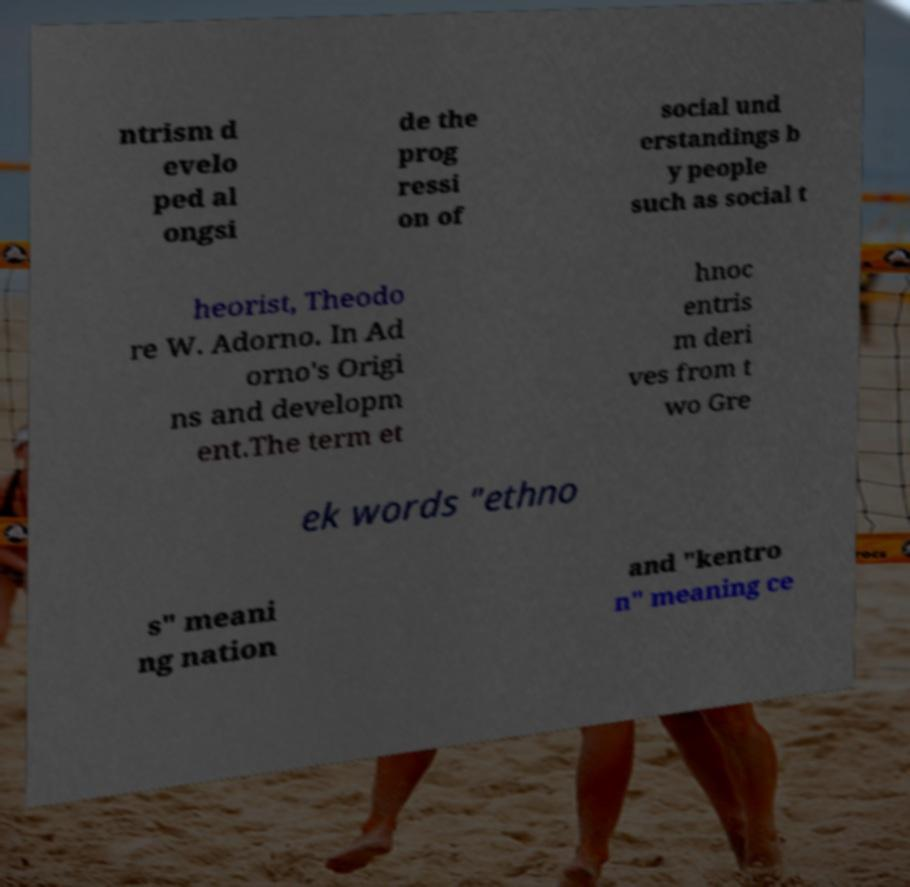Please identify and transcribe the text found in this image. ntrism d evelo ped al ongsi de the prog ressi on of social und erstandings b y people such as social t heorist, Theodo re W. Adorno. In Ad orno's Origi ns and developm ent.The term et hnoc entris m deri ves from t wo Gre ek words "ethno s" meani ng nation and "kentro n" meaning ce 